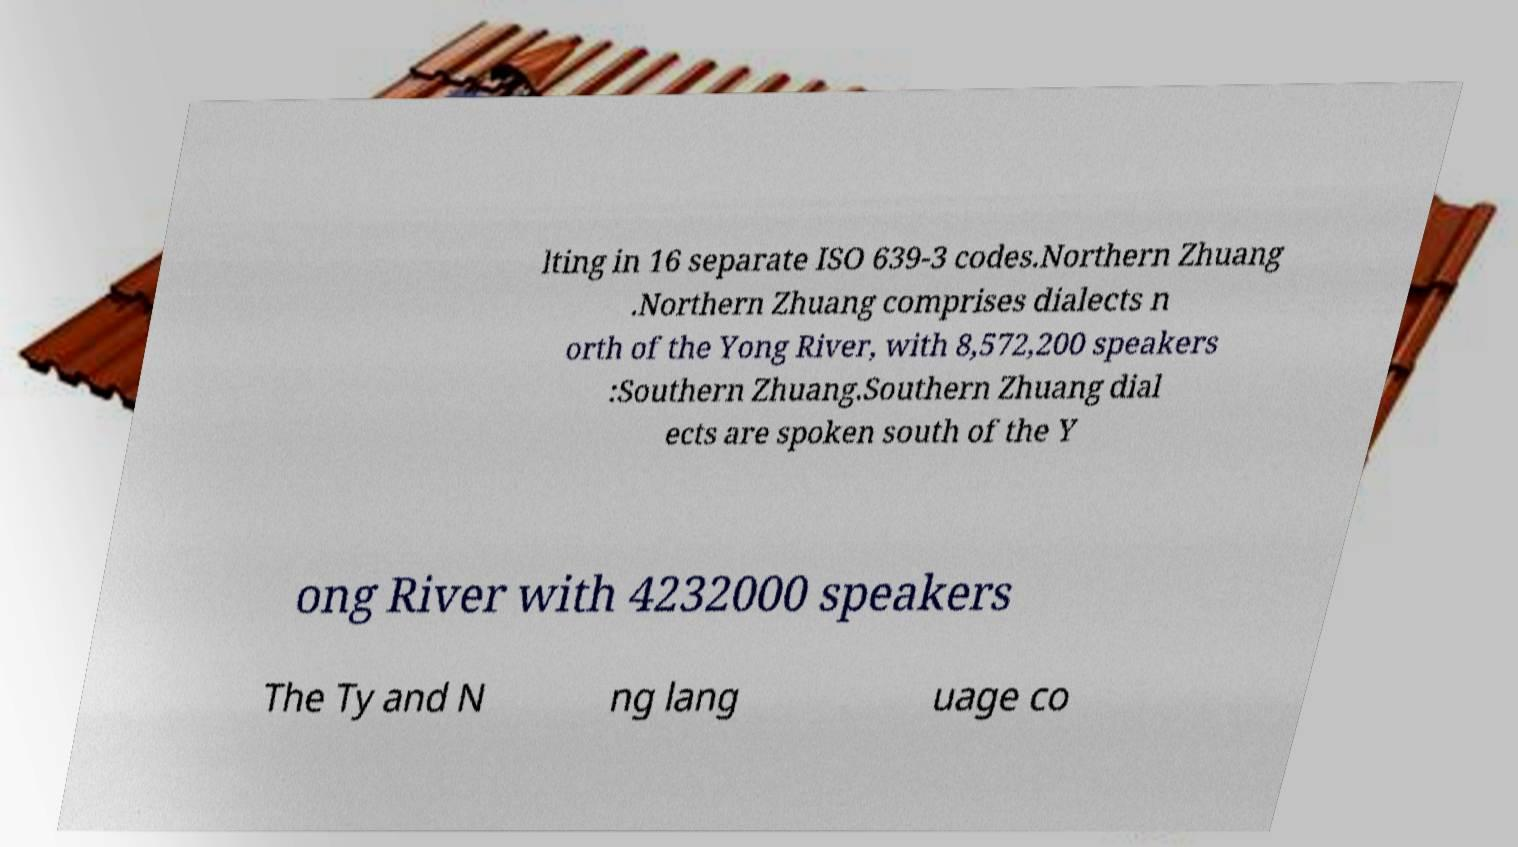For documentation purposes, I need the text within this image transcribed. Could you provide that? lting in 16 separate ISO 639-3 codes.Northern Zhuang .Northern Zhuang comprises dialects n orth of the Yong River, with 8,572,200 speakers :Southern Zhuang.Southern Zhuang dial ects are spoken south of the Y ong River with 4232000 speakers The Ty and N ng lang uage co 